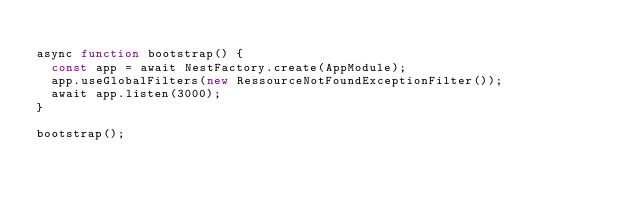Convert code to text. <code><loc_0><loc_0><loc_500><loc_500><_TypeScript_>
async function bootstrap() {
  const app = await NestFactory.create(AppModule);
  app.useGlobalFilters(new RessourceNotFoundExceptionFilter());
  await app.listen(3000);
}

bootstrap();
</code> 